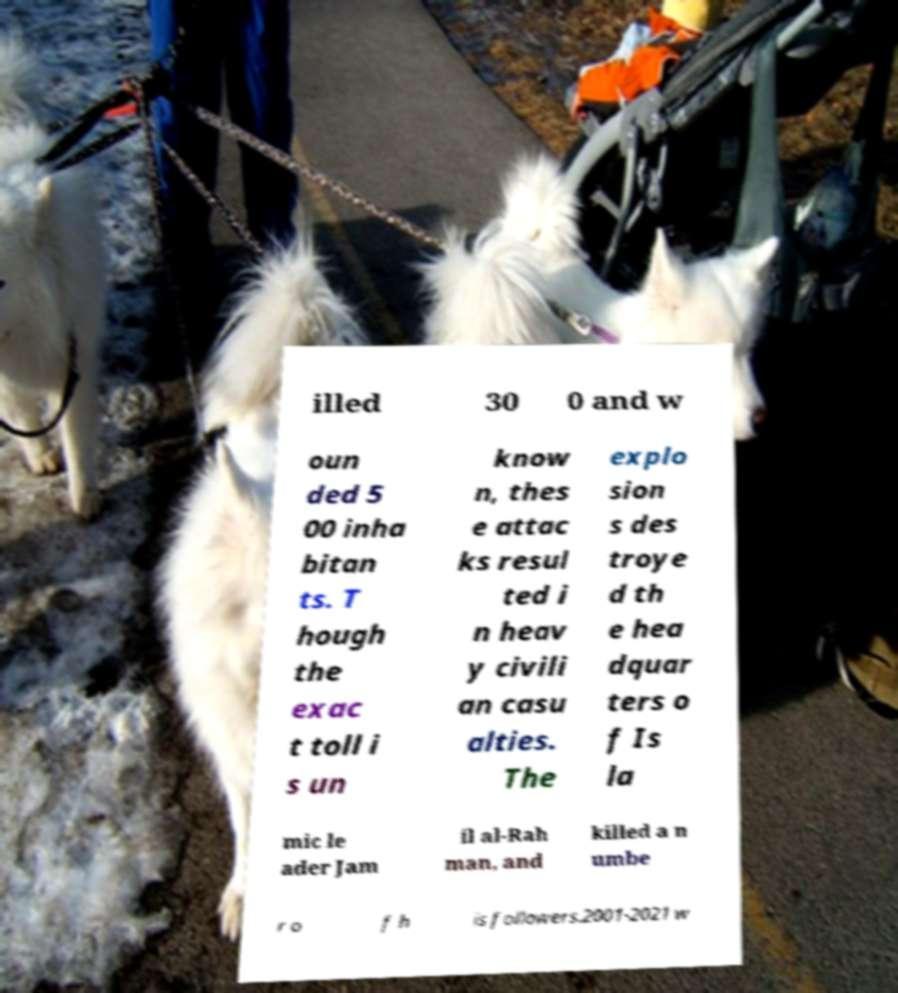Can you accurately transcribe the text from the provided image for me? illed 30 0 and w oun ded 5 00 inha bitan ts. T hough the exac t toll i s un know n, thes e attac ks resul ted i n heav y civili an casu alties. The explo sion s des troye d th e hea dquar ters o f Is la mic le ader Jam il al-Rah man, and killed a n umbe r o f h is followers.2001-2021 w 